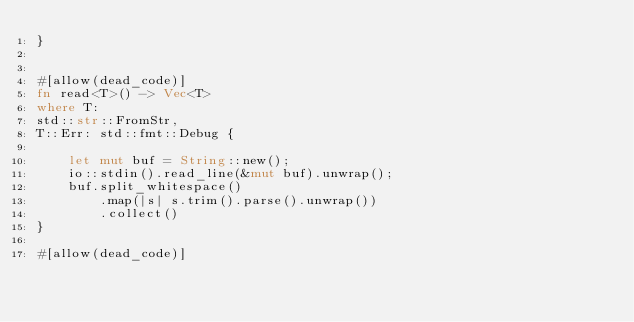<code> <loc_0><loc_0><loc_500><loc_500><_Rust_>}


#[allow(dead_code)]
fn read<T>() -> Vec<T>
where T:
std::str::FromStr,
T::Err: std::fmt::Debug {

    let mut buf = String::new();
    io::stdin().read_line(&mut buf).unwrap();
    buf.split_whitespace()
        .map(|s| s.trim().parse().unwrap())
        .collect()
}

#[allow(dead_code)]</code> 